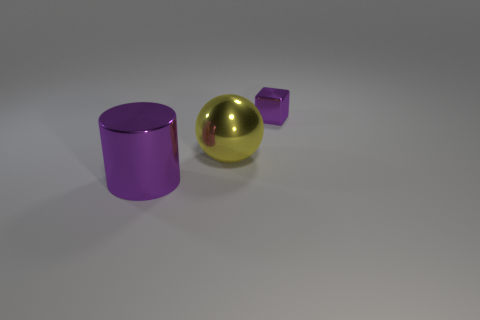Add 3 purple cylinders. How many objects exist? 6 Subtract 1 spheres. How many spheres are left? 0 Subtract 0 blue spheres. How many objects are left? 3 Subtract all cubes. How many objects are left? 2 Subtract all green spheres. Subtract all yellow cylinders. How many spheres are left? 1 Subtract all big green rubber objects. Subtract all small purple metallic cubes. How many objects are left? 2 Add 2 purple metallic blocks. How many purple metallic blocks are left? 3 Add 2 brown shiny spheres. How many brown shiny spheres exist? 2 